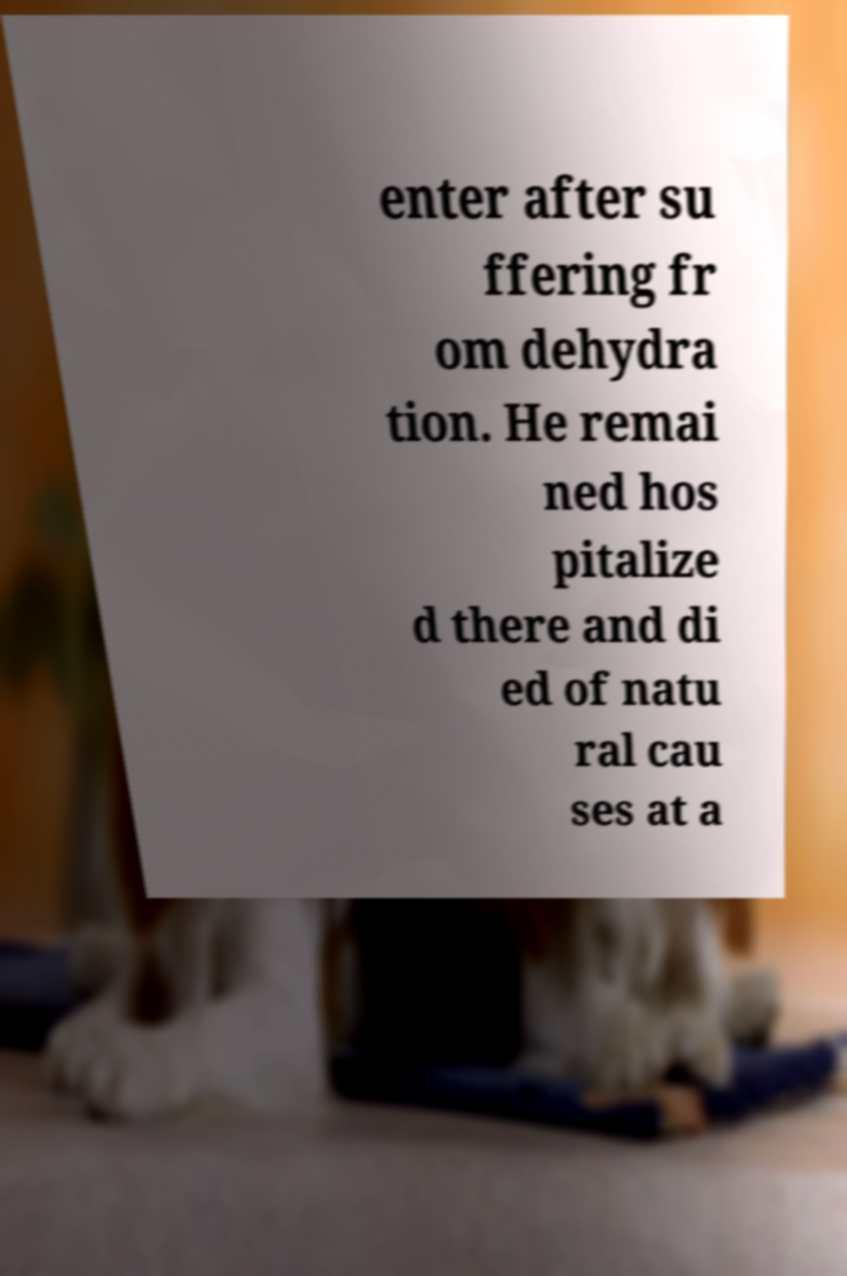Please identify and transcribe the text found in this image. enter after su ffering fr om dehydra tion. He remai ned hos pitalize d there and di ed of natu ral cau ses at a 